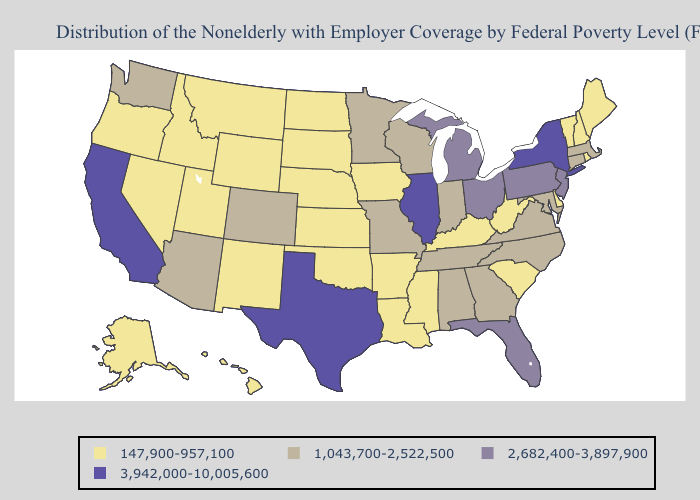Name the states that have a value in the range 3,942,000-10,005,600?
Answer briefly. California, Illinois, New York, Texas. Among the states that border Missouri , which have the lowest value?
Short answer required. Arkansas, Iowa, Kansas, Kentucky, Nebraska, Oklahoma. Does Nevada have the highest value in the West?
Write a very short answer. No. Among the states that border Louisiana , does Texas have the highest value?
Be succinct. Yes. Which states have the lowest value in the USA?
Concise answer only. Alaska, Arkansas, Delaware, Hawaii, Idaho, Iowa, Kansas, Kentucky, Louisiana, Maine, Mississippi, Montana, Nebraska, Nevada, New Hampshire, New Mexico, North Dakota, Oklahoma, Oregon, Rhode Island, South Carolina, South Dakota, Utah, Vermont, West Virginia, Wyoming. What is the lowest value in states that border Alabama?
Keep it brief. 147,900-957,100. Among the states that border Colorado , does Oklahoma have the highest value?
Give a very brief answer. No. Among the states that border Missouri , does Iowa have the lowest value?
Concise answer only. Yes. Which states have the lowest value in the MidWest?
Concise answer only. Iowa, Kansas, Nebraska, North Dakota, South Dakota. Name the states that have a value in the range 147,900-957,100?
Concise answer only. Alaska, Arkansas, Delaware, Hawaii, Idaho, Iowa, Kansas, Kentucky, Louisiana, Maine, Mississippi, Montana, Nebraska, Nevada, New Hampshire, New Mexico, North Dakota, Oklahoma, Oregon, Rhode Island, South Carolina, South Dakota, Utah, Vermont, West Virginia, Wyoming. What is the value of Louisiana?
Short answer required. 147,900-957,100. Among the states that border Kansas , which have the lowest value?
Concise answer only. Nebraska, Oklahoma. What is the value of Wyoming?
Write a very short answer. 147,900-957,100. Does Arkansas have the same value as New Hampshire?
Answer briefly. Yes. Name the states that have a value in the range 147,900-957,100?
Write a very short answer. Alaska, Arkansas, Delaware, Hawaii, Idaho, Iowa, Kansas, Kentucky, Louisiana, Maine, Mississippi, Montana, Nebraska, Nevada, New Hampshire, New Mexico, North Dakota, Oklahoma, Oregon, Rhode Island, South Carolina, South Dakota, Utah, Vermont, West Virginia, Wyoming. 